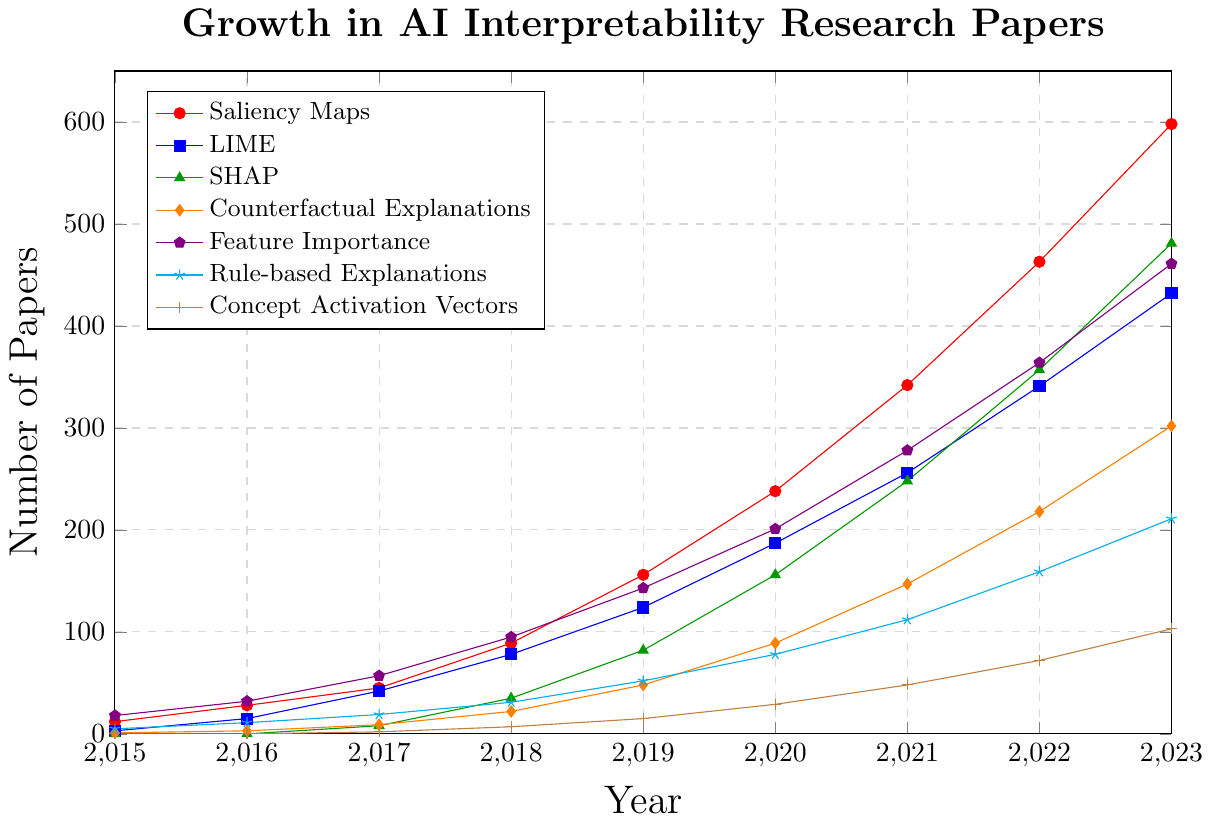What's the subfield with the highest growth in published papers from 2022 to 2023? Observe the end points between 2022 and 2023 for each subfield. Saliency Maps, starting at 463 and reaching 598, show the largest increase in the number of papers.
Answer: Saliency Maps How many papers on SHAP were published in 2020 compared to 2019? Find the points for SHAP in 2019 and 2020. In 2019, 82 papers were published, and in 2020, 156 papers were published. The difference is 156 - 82.
Answer: 74 What is the average number of papers published on Counterfactual Explanations from 2015 to 2023? Sum the number of papers published each year from 2015 to 2023 for Counterfactual Explanations: 1 + 3 + 9 + 22 + 48 + 89 + 147 + 218 + 302. Calculate the average by dividing by the number of years (9).
Answer: 93.22 Which year saw the highest number of papers published on Rule-based Explanations? Identify the maximum point for Rule-based Explanations between 2015 and 2023. The highest number of papers published is in 2023.
Answer: 2023 How does the growth trend of LIME compare with Feature Importance from 2016 to 2018? Examine the slopes of LIME and Feature Importance between 2016 and 2018. LIME increased from 15 to 78, translating into a difference of 63. Feature Importance grew from 32 to 95, giving a difference of 63 as well. Both subfields grew by the same number of papers.
Answer: Same growth What was the total number of papers published on SHAP and Concept Activation Vectors combined in 2017? Refer to 2017: 8 papers on SHAP and 2 on Concept Activation Vectors. The total is 8 + 2.
Answer: 10 Which subfield had the smallest number of papers published in 2015? Look at the 2015 data points for each subfield. Both SHAP and Concept Activation Vectors have 0 papers, which is the smallest number.
Answer: SHAP and Concept Activation Vectors How many more papers were published on Feature Importance than Rule-based Explanations in 2021? In 2021, 278 papers were published on Feature Importance and 112 on Rule-based Explanations. The difference is 278 - 112.
Answer: 166 What's the ratio of the number of papers published on Saliency Maps to those on LIME in 2023? In 2023, 598 papers were published on Saliency Maps and 432 on LIME. The ratio is 598 to 432, which can be simplified to about 1.38 when divided by the greatest common divisor.
Answer: 1.38:1 